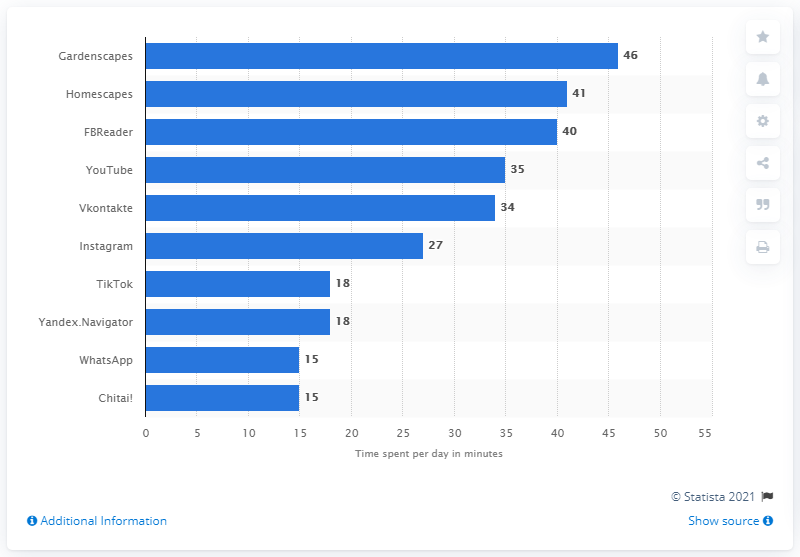Highlight a few significant elements in this photo. According to data collected during the first six months of 2019, the mobile app that was used by Russian users for the longest amount of time was "Gardenscapes. The average daily playtime for Gardenscapes players was found to be approximately 46 minutes per day. Vkontakte was the fifth most popular social media network in Russia in 2019. 